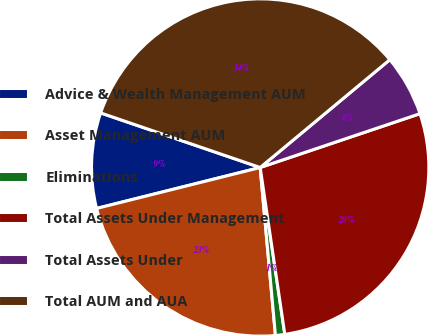Convert chart. <chart><loc_0><loc_0><loc_500><loc_500><pie_chart><fcel>Advice & Wealth Management AUM<fcel>Asset Management AUM<fcel>Eliminations<fcel>Total Assets Under Management<fcel>Total Assets Under<fcel>Total AUM and AUA<nl><fcel>9.15%<fcel>22.54%<fcel>0.89%<fcel>27.84%<fcel>5.87%<fcel>33.71%<nl></chart> 